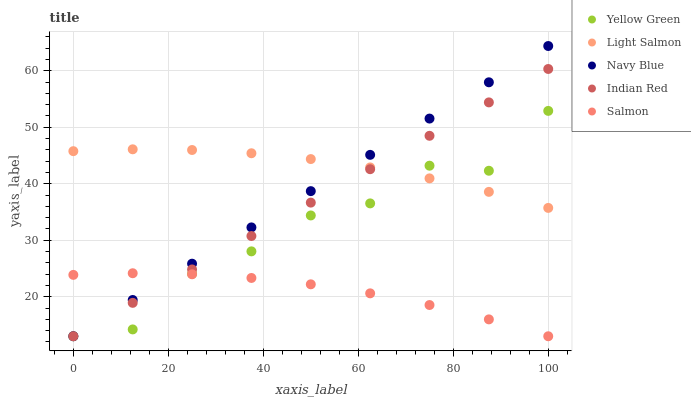Does Salmon have the minimum area under the curve?
Answer yes or no. Yes. Does Light Salmon have the maximum area under the curve?
Answer yes or no. Yes. Does Light Salmon have the minimum area under the curve?
Answer yes or no. No. Does Salmon have the maximum area under the curve?
Answer yes or no. No. Is Indian Red the smoothest?
Answer yes or no. Yes. Is Yellow Green the roughest?
Answer yes or no. Yes. Is Light Salmon the smoothest?
Answer yes or no. No. Is Light Salmon the roughest?
Answer yes or no. No. Does Navy Blue have the lowest value?
Answer yes or no. Yes. Does Light Salmon have the lowest value?
Answer yes or no. No. Does Navy Blue have the highest value?
Answer yes or no. Yes. Does Light Salmon have the highest value?
Answer yes or no. No. Is Salmon less than Light Salmon?
Answer yes or no. Yes. Is Light Salmon greater than Salmon?
Answer yes or no. Yes. Does Light Salmon intersect Yellow Green?
Answer yes or no. Yes. Is Light Salmon less than Yellow Green?
Answer yes or no. No. Is Light Salmon greater than Yellow Green?
Answer yes or no. No. Does Salmon intersect Light Salmon?
Answer yes or no. No. 